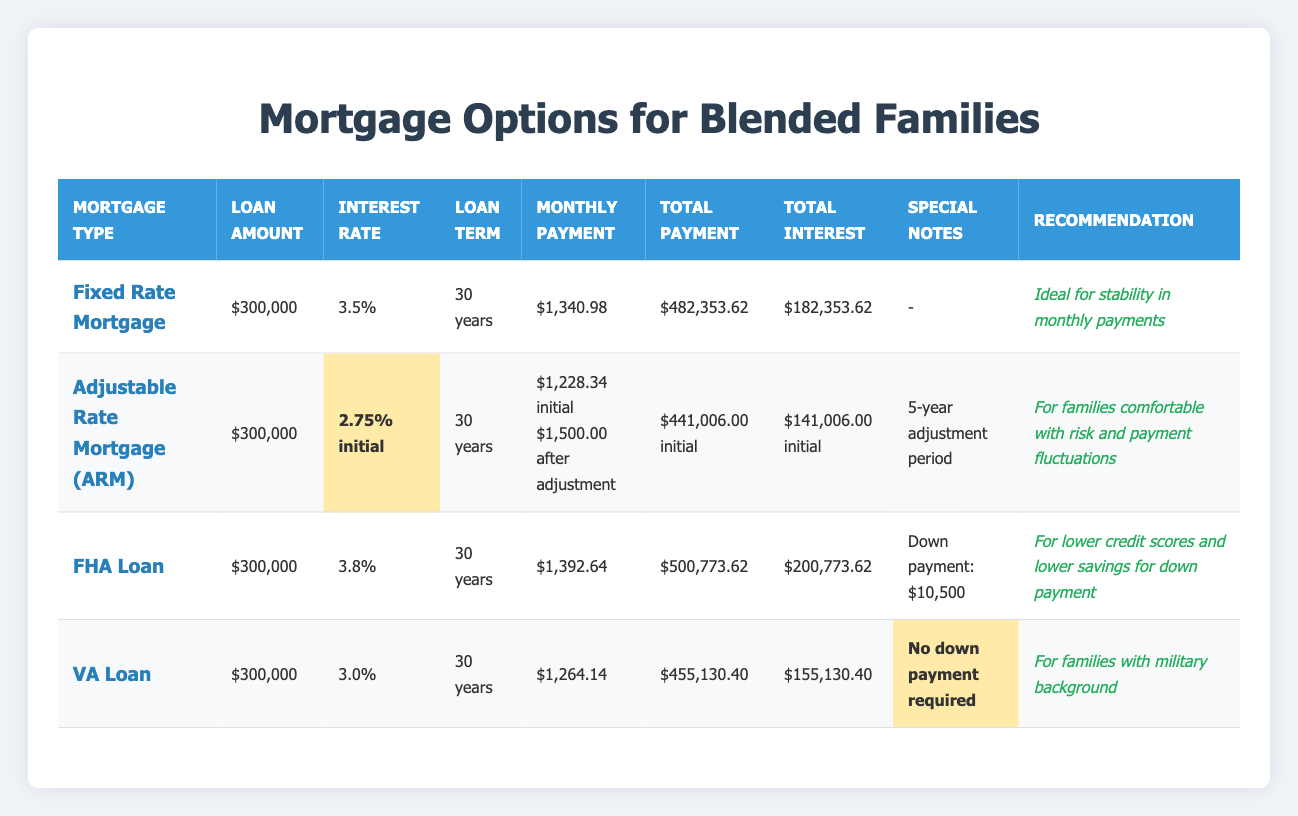What is the monthly payment for a Fixed Rate Mortgage? The table lists the monthly payment for a Fixed Rate Mortgage as $1,340.98.
Answer: $1,340.98 What is the total interest paid over the life of the FHA Loan? According to the table, the total interest for the FHA Loan is $200,773.62, as directly stated in the corresponding row.
Answer: $200,773.62 Is the VA Loan the only option that requires no down payment? The table indicates that the VA Loan has a down payment of $0, while the FHA Loan requires a down payment of $10,500. Therefore, the VA Loan is indeed the only option listed that requires no down payment.
Answer: Yes What is the difference in total payment between the Fixed Rate Mortgage and the Adjustable Rate Mortgage after the initial period? The total payment for the Fixed Rate Mortgage is $482,353.62, and for the Adjustable Rate Mortgage, it is $441,006.00 after the initial period. The difference is $482,353.62 - $441,006.00 = $41,347.62.
Answer: $41,347.62 Which mortgage option has the lowest monthly payment? The table displays the monthly payments for each mortgage option. The VA Loan at $1,264.14 is the lowest when compared to the others: Fixed Rate Mortgage ($1,340.98), FHA Loan ($1,392.64), and Adjustable Rate Mortgage (initially $1,228.34 but requires higher payments later).
Answer: VA Loan What is the total interest amount for the Adjustable Rate Mortgage compared to the Fixed Rate Mortgage? For the Adjustable Rate Mortgage, the total interest paid is $141,006.00 for the initial period, while for the Fixed Rate Mortgage, it is $182,353.62. To find the comparison, we see that the Fixed Rate Mortgage has $182,353.62 - $141,006.00 = $41,347.62 more in total interest paid than the Adjustable Rate Mortgage initially.
Answer: $41,347.62 Which mortgage option is recommended for blended families with military backgrounds? The table states that the VA Loan is specifically recommended for blended families with military backgrounds, as mentioned in the recommendation column.
Answer: VA Loan What is the total payment for the Adjustable Rate Mortgage if the interest rate increases after the initial period? The table states the total payment for the Adjustable Rate Mortgage during the initial period is $441,006.00. However, the monthly payment increases to $1,500.00 after adjustment; therefore, the total payment will likely be higher than $441,006.00, but the exact figure isn’t provided in the table.
Answer: Initial payment is $441,006.00 (total may increase) 